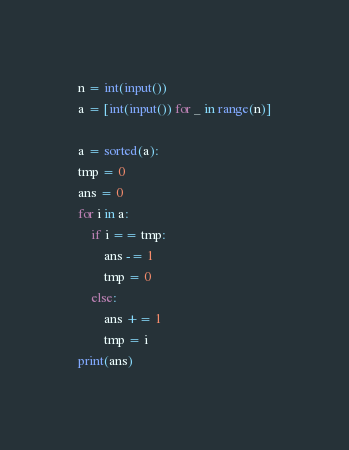<code> <loc_0><loc_0><loc_500><loc_500><_Python_>n = int(input())
a = [int(input()) for _ in range(n)]

a = sorted(a):
tmp = 0
ans = 0
for i in a:
    if i == tmp:
        ans -= 1
        tmp = 0
    else:
        ans += 1
        tmp = i
print(ans)</code> 